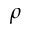Convert formula to latex. <formula><loc_0><loc_0><loc_500><loc_500>\rho</formula> 